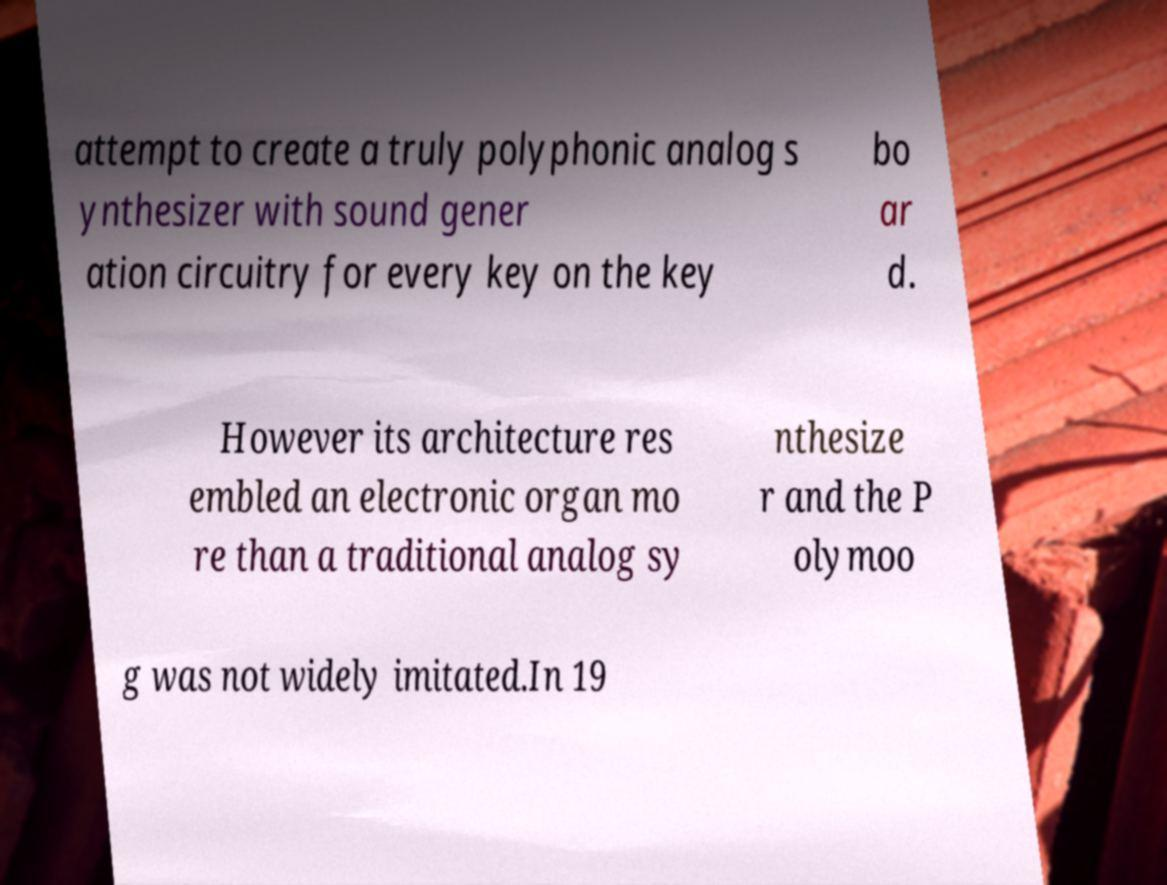For documentation purposes, I need the text within this image transcribed. Could you provide that? attempt to create a truly polyphonic analog s ynthesizer with sound gener ation circuitry for every key on the key bo ar d. However its architecture res embled an electronic organ mo re than a traditional analog sy nthesize r and the P olymoo g was not widely imitated.In 19 